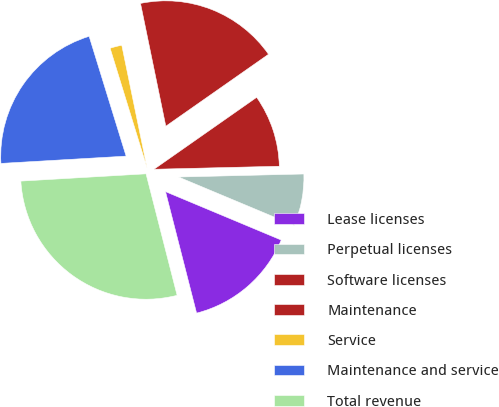Convert chart. <chart><loc_0><loc_0><loc_500><loc_500><pie_chart><fcel>Lease licenses<fcel>Perpetual licenses<fcel>Software licenses<fcel>Maintenance<fcel>Service<fcel>Maintenance and service<fcel>Total revenue<nl><fcel>14.71%<fcel>6.69%<fcel>9.34%<fcel>18.51%<fcel>1.53%<fcel>21.16%<fcel>28.06%<nl></chart> 